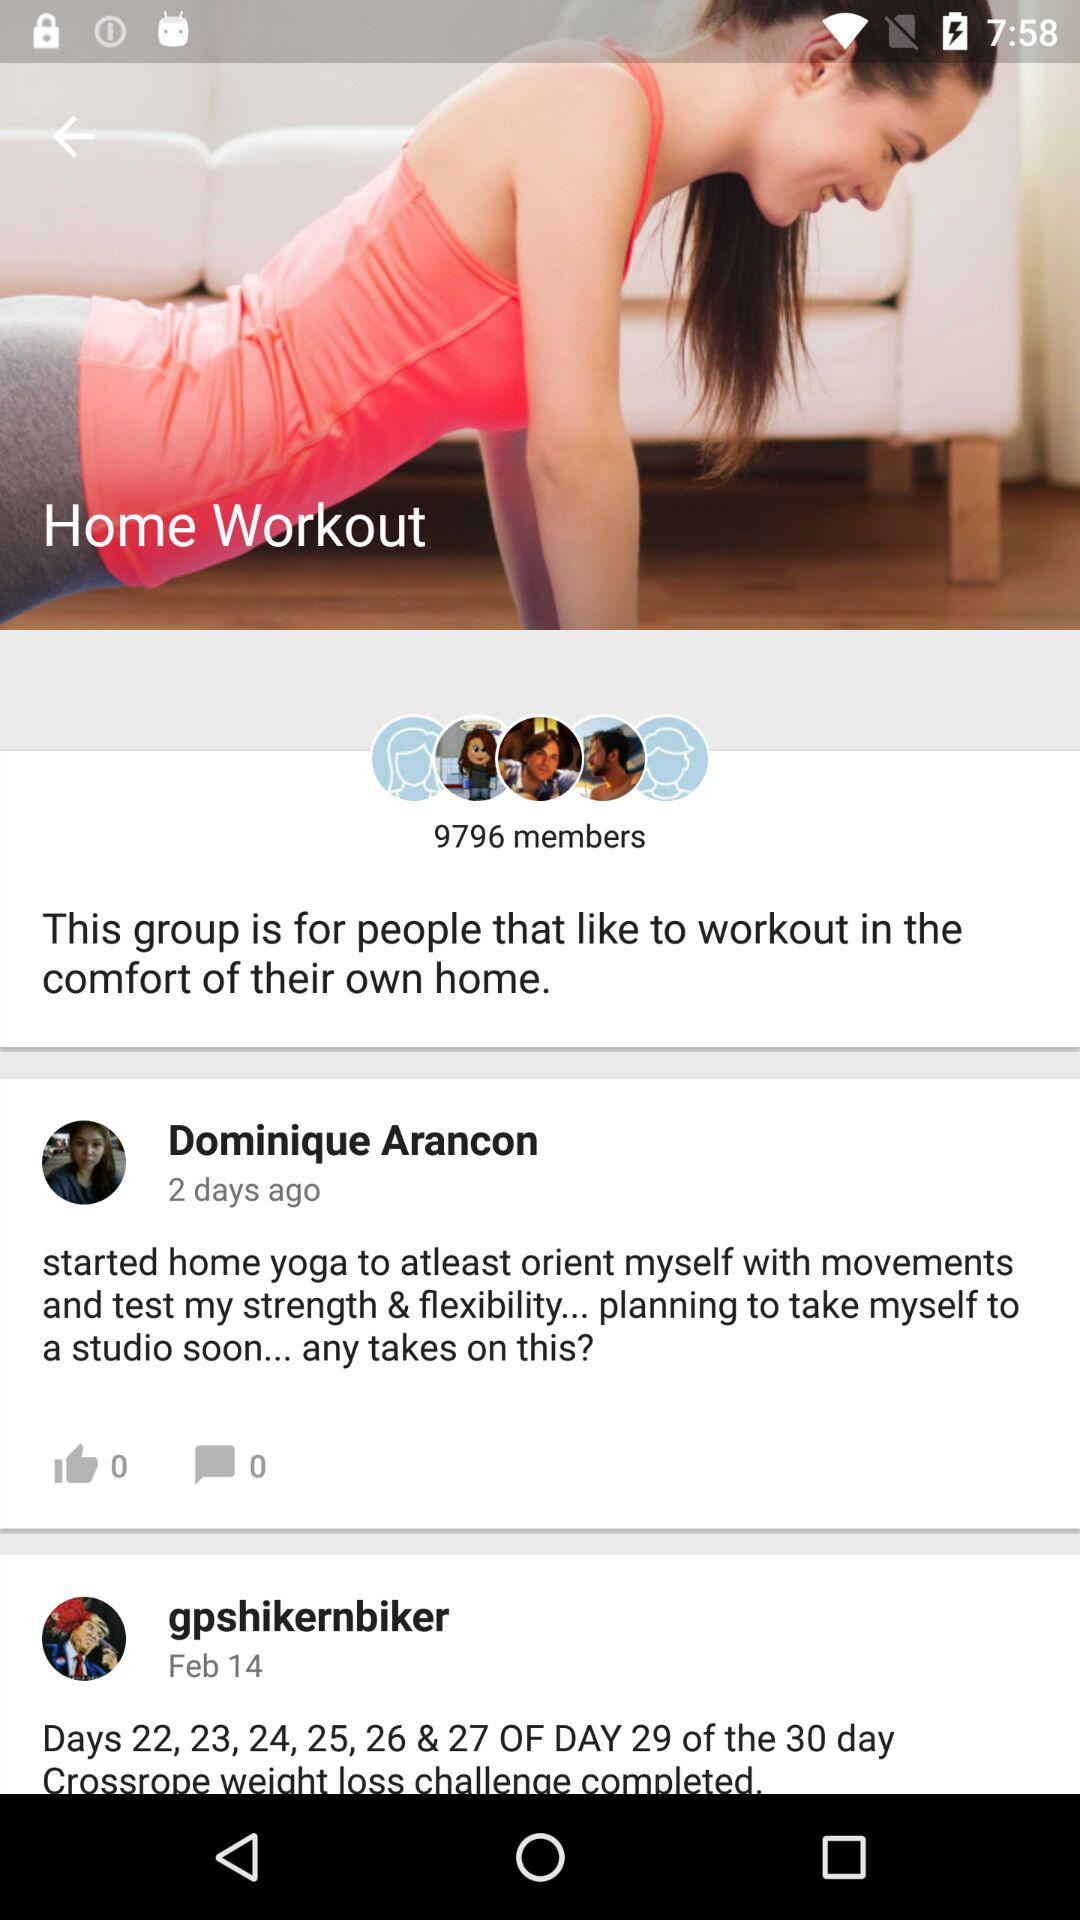How many people are in the group?
Answer the question using a single word or phrase. 9796 